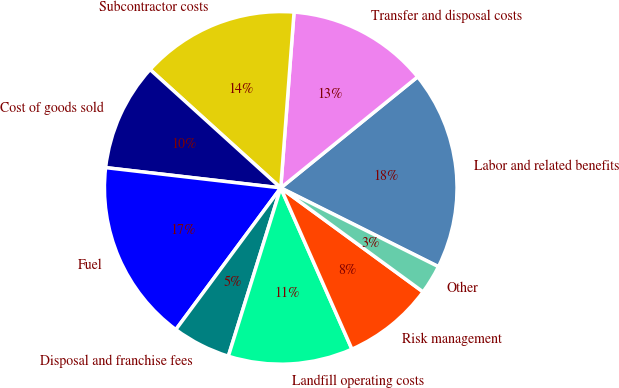Convert chart. <chart><loc_0><loc_0><loc_500><loc_500><pie_chart><fcel>Labor and related benefits<fcel>Transfer and disposal costs<fcel>Subcontractor costs<fcel>Cost of goods sold<fcel>Fuel<fcel>Disposal and franchise fees<fcel>Landfill operating costs<fcel>Risk management<fcel>Other<nl><fcel>18.22%<fcel>12.95%<fcel>14.49%<fcel>9.88%<fcel>16.69%<fcel>5.34%<fcel>11.42%<fcel>8.34%<fcel>2.67%<nl></chart> 